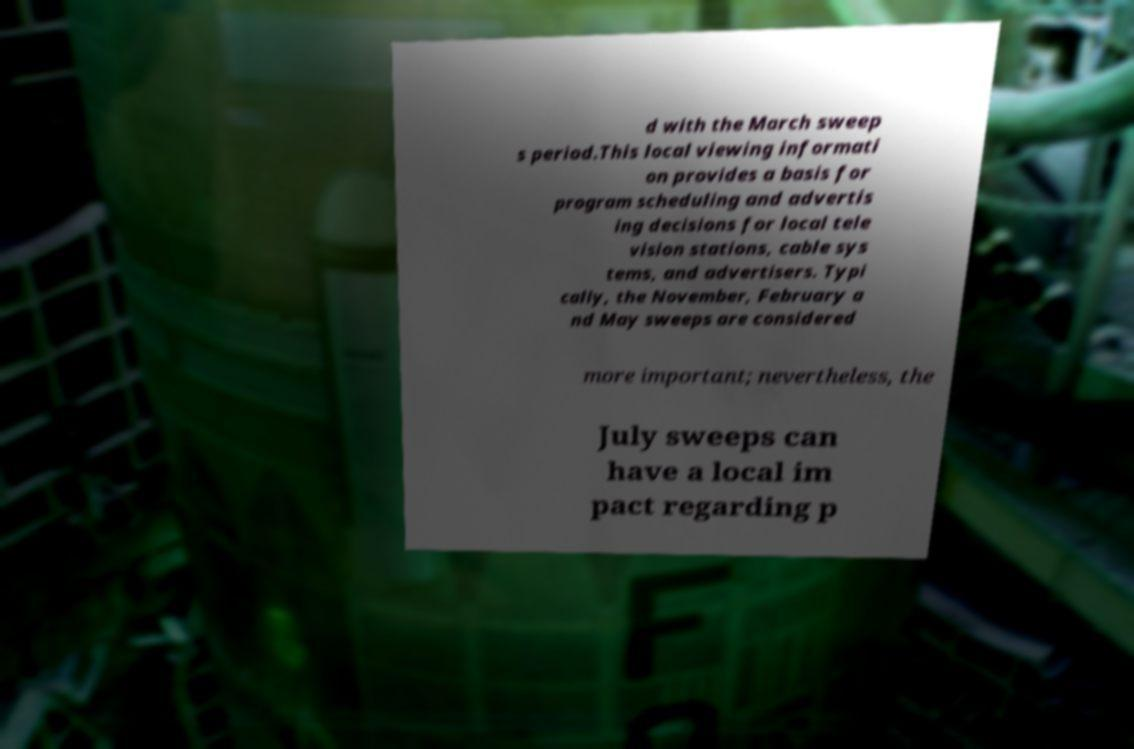Can you read and provide the text displayed in the image?This photo seems to have some interesting text. Can you extract and type it out for me? d with the March sweep s period.This local viewing informati on provides a basis for program scheduling and advertis ing decisions for local tele vision stations, cable sys tems, and advertisers. Typi cally, the November, February a nd May sweeps are considered more important; nevertheless, the July sweeps can have a local im pact regarding p 